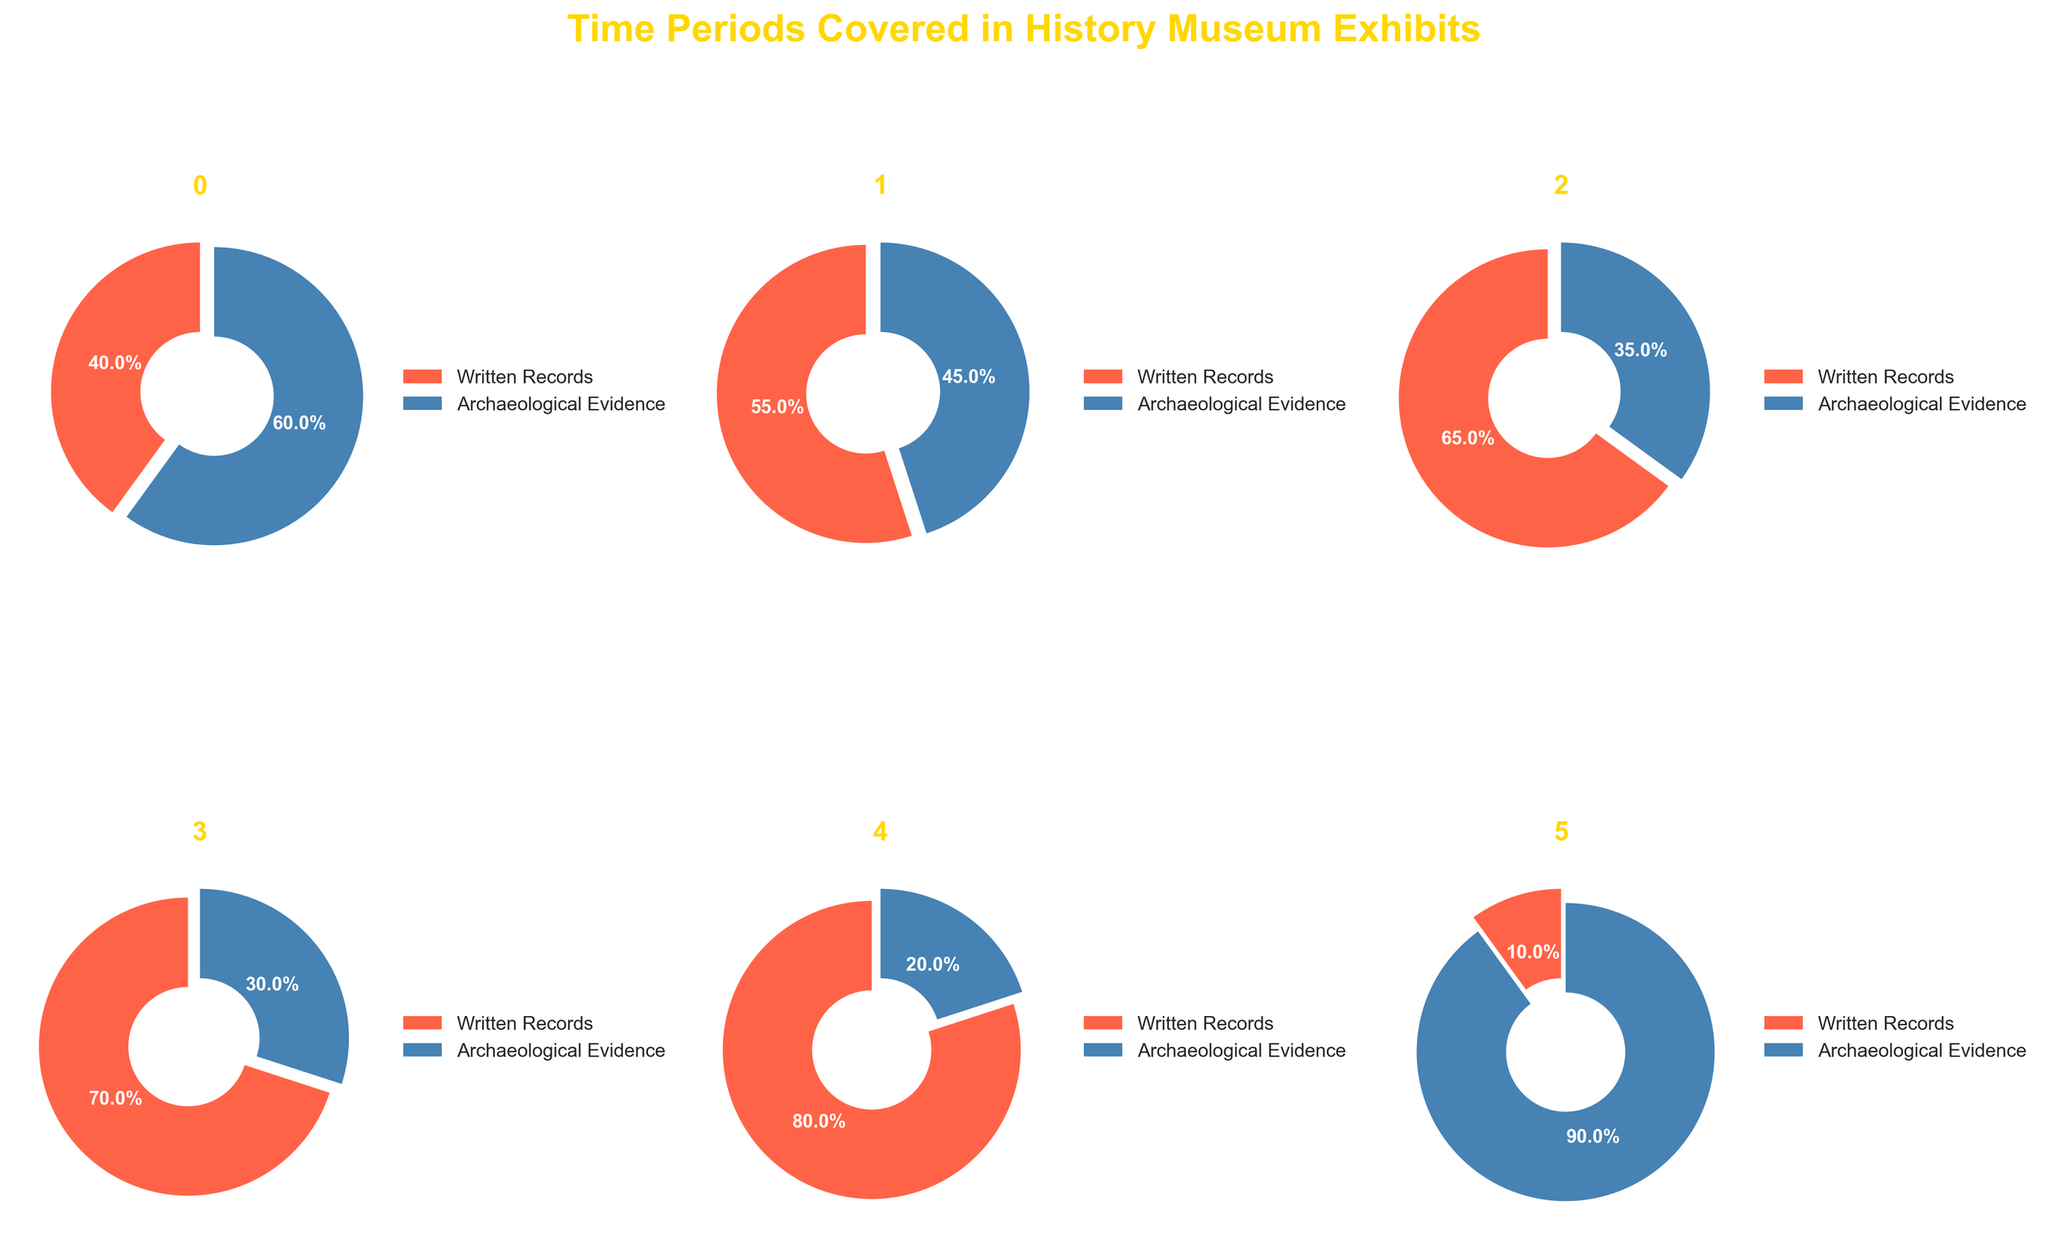What is the title of the subplot? The title is typically placed at the top of a figure. It summarizes the content of the figure. From the given information, the title is "Time Periods Covered in History Museum Exhibits".
Answer: Time Periods Covered in History Museum Exhibits Which era has the highest percentage of exhibits based on written records? To answer this question, we look for the pie chart with the largest section dedicated to written records. From the data, we see that the Modern Era has the highest at 80%.
Answer: Modern Era Which era has the highest percentage of exhibits based on archaeological evidence? To find this, we need to look for the pie chart where the archaeological evidence section occupies the largest proportion. For the Prehistory era, it accounts for 90%.
Answer: Prehistory Compare the proportion of written records between the Renaissance and the Industrial Revolution periods. Which is higher? We compare the percentages directly from the data. The Renaissance has 65% written records, while the Industrial Revolution has 70%. Thus, the Industrial Revolution is higher.
Answer: Industrial Revolution How do the proportions of written records in Medieval Period and Ancient Civilizations compare? From the data, we can see:
1. Medieval Period: 55% written records
2. Ancient Civilizations: 40% written records
Hence, the Medieval Period has a higher percentage of exhibits based on written records.
Answer: Medieval Period Which eras have a higher percentage of archaeological evidence than written records? We need to compare the percentages for each era:
1. Ancient Civilizations: 60% archaeological, 40% written
2. Medieval Period: 45% archaeological, 55% written
3. Renaissance: 35% archaeological, 65% written
4. Industrial Revolution: 30% archaeological, 70% written
5. Modern Era: 20% archaeological, 80% written
6. Prehistory: 90% archaeological, 10% written
Based on this comparison, Ancient Civilizations and Prehistory have more archaeological evidence than written records.
Answer: Ancient Civilizations and Prehistory Sum up the percentages of written records for all periods. What is the result? Adding the written records percentages from the data:
40% (Ancient Civilizations) + 55% (Medieval Period) + 65% (Renaissance) + 70% (Industrial Revolution) + 80% (Modern Era) + 10% (Prehistory) = 320%
Answer: 320% Calculate the average percentage of written records across all eras. To find the average, divide the total sum of written records percentages by the number of periods:
(40% + 55% + 65% + 70% + 80% + 10%) / 6 ≈ 53.33%
Answer: 53.33% Is the proportion of written records higher than archaeological evidence for the Renaissance period? We compare the percentages for the Renaissance from the data:
Written records: 65%
Archaeological evidence: 35%
Since 65% is greater than 35%, the written records proportion is higher.
Answer: Yes 